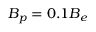Convert formula to latex. <formula><loc_0><loc_0><loc_500><loc_500>{ B _ { p } } = 0 . 1 { B _ { e } }</formula> 